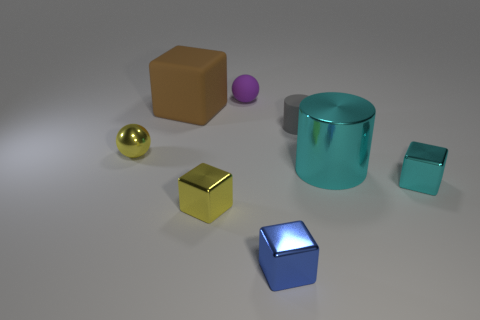Subtract 1 cubes. How many cubes are left? 3 Add 1 big brown spheres. How many objects exist? 9 Subtract all balls. How many objects are left? 6 Subtract 0 purple cubes. How many objects are left? 8 Subtract all tiny red shiny spheres. Subtract all brown rubber cubes. How many objects are left? 7 Add 5 tiny cyan things. How many tiny cyan things are left? 6 Add 4 tiny blue things. How many tiny blue things exist? 5 